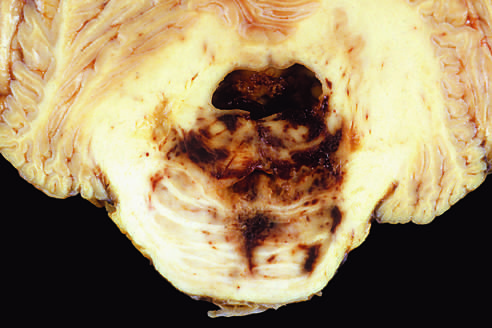what does disruption of the vessels that enter the pons along the midline lead to?
Answer the question using a single word or phrase. Hemorrhage 